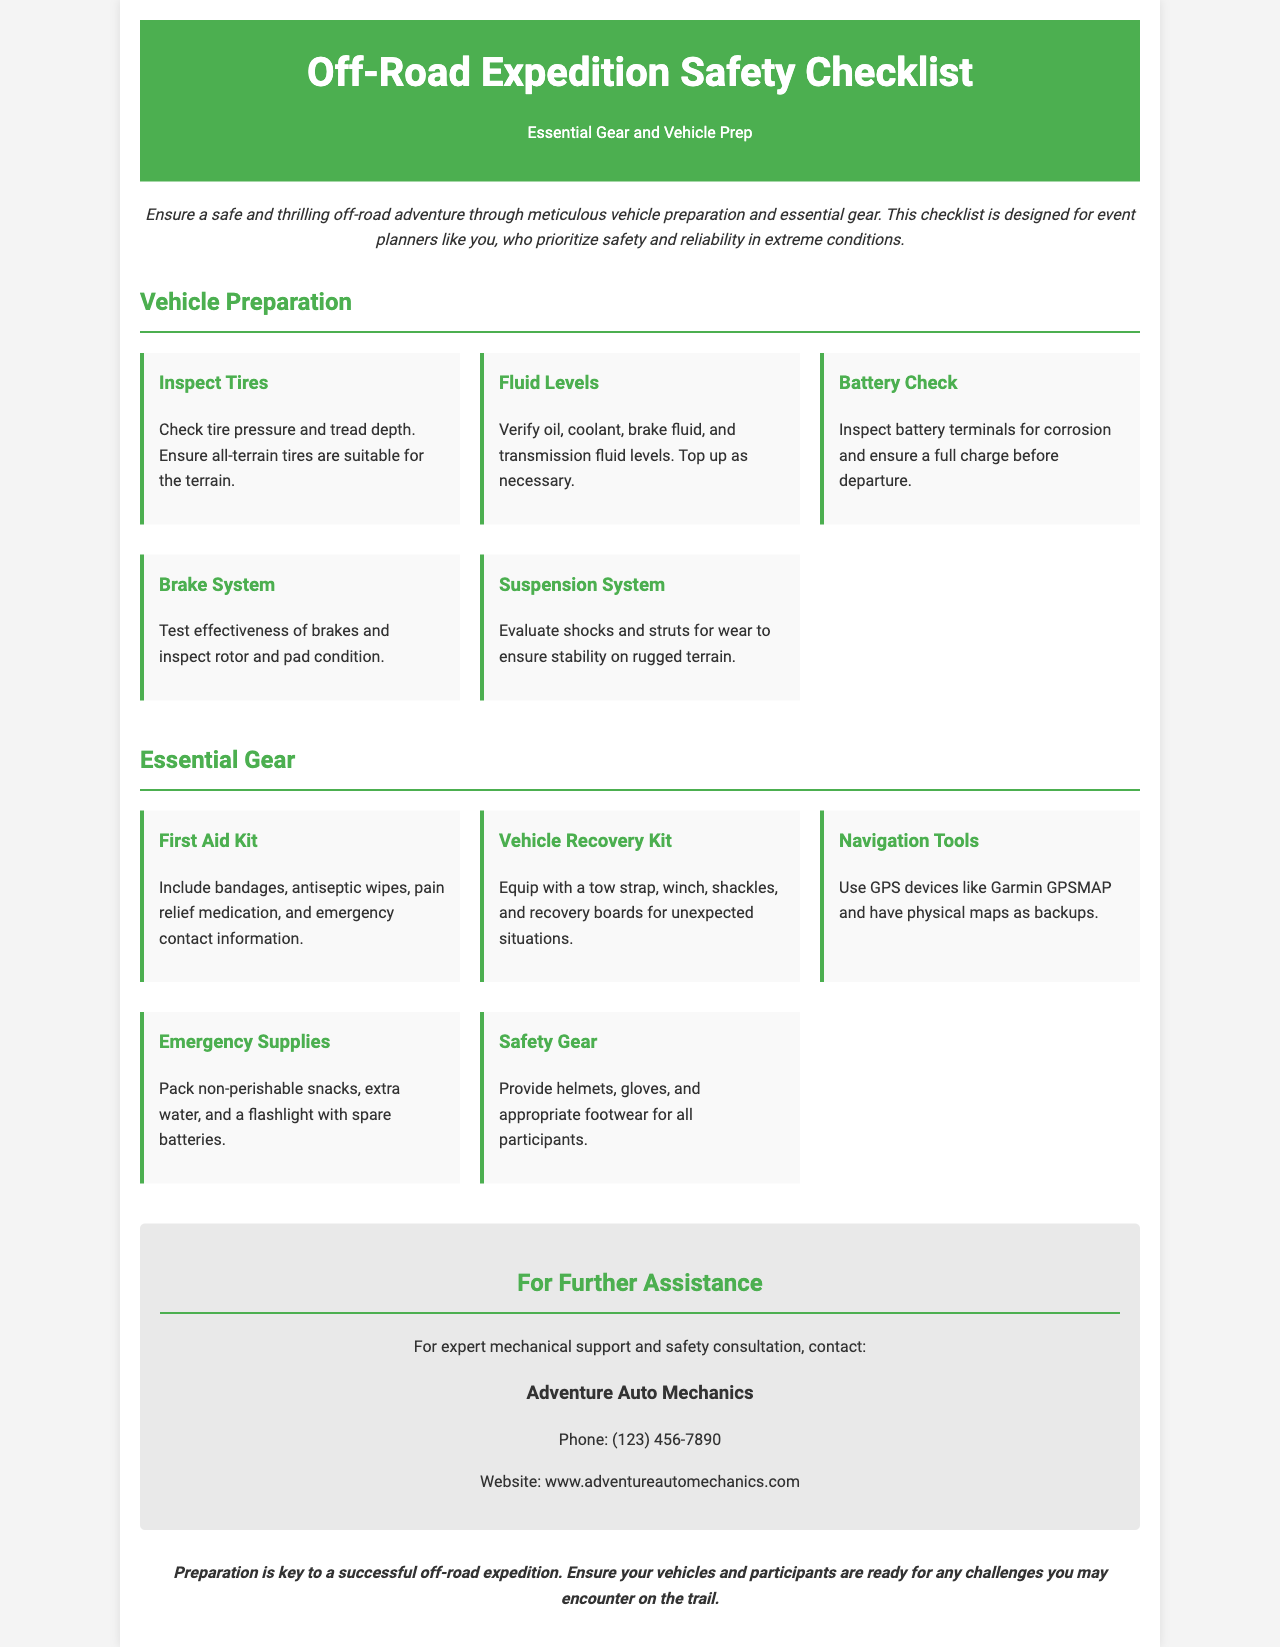what is the title of the document? The title is stated at the top of the document, which is "Off-Road Expedition Safety Checklist".
Answer: Off-Road Expedition Safety Checklist how many vehicle preparation items are listed? The document lists five items under the Vehicle Preparation section.
Answer: 5 what is included in the vehicle recovery kit? The document specifies items like a tow strap, winch, shackles, and recovery boards in the Vehicle Recovery Kit.
Answer: Tow strap, winch, shackles, recovery boards who can be contacted for further assistance? The document lists "Adventure Auto Mechanics" as the contact for further assistance.
Answer: Adventure Auto Mechanics what type of items does the essential gear section cover? The essential gear section lists items related to safety, navigation, and emergency supplies.
Answer: Safety, navigation, emergency supplies how many essential gear items are mentioned? The document mentions five items under the Essential Gear section.
Answer: 5 what should be inspected as part of the battery check? The document requires the inspection of battery terminals for corrosion.
Answer: Battery terminals for corrosion which company’s contact information is provided? The contact information provided is for "Adventure Auto Mechanics".
Answer: Adventure Auto Mechanics 